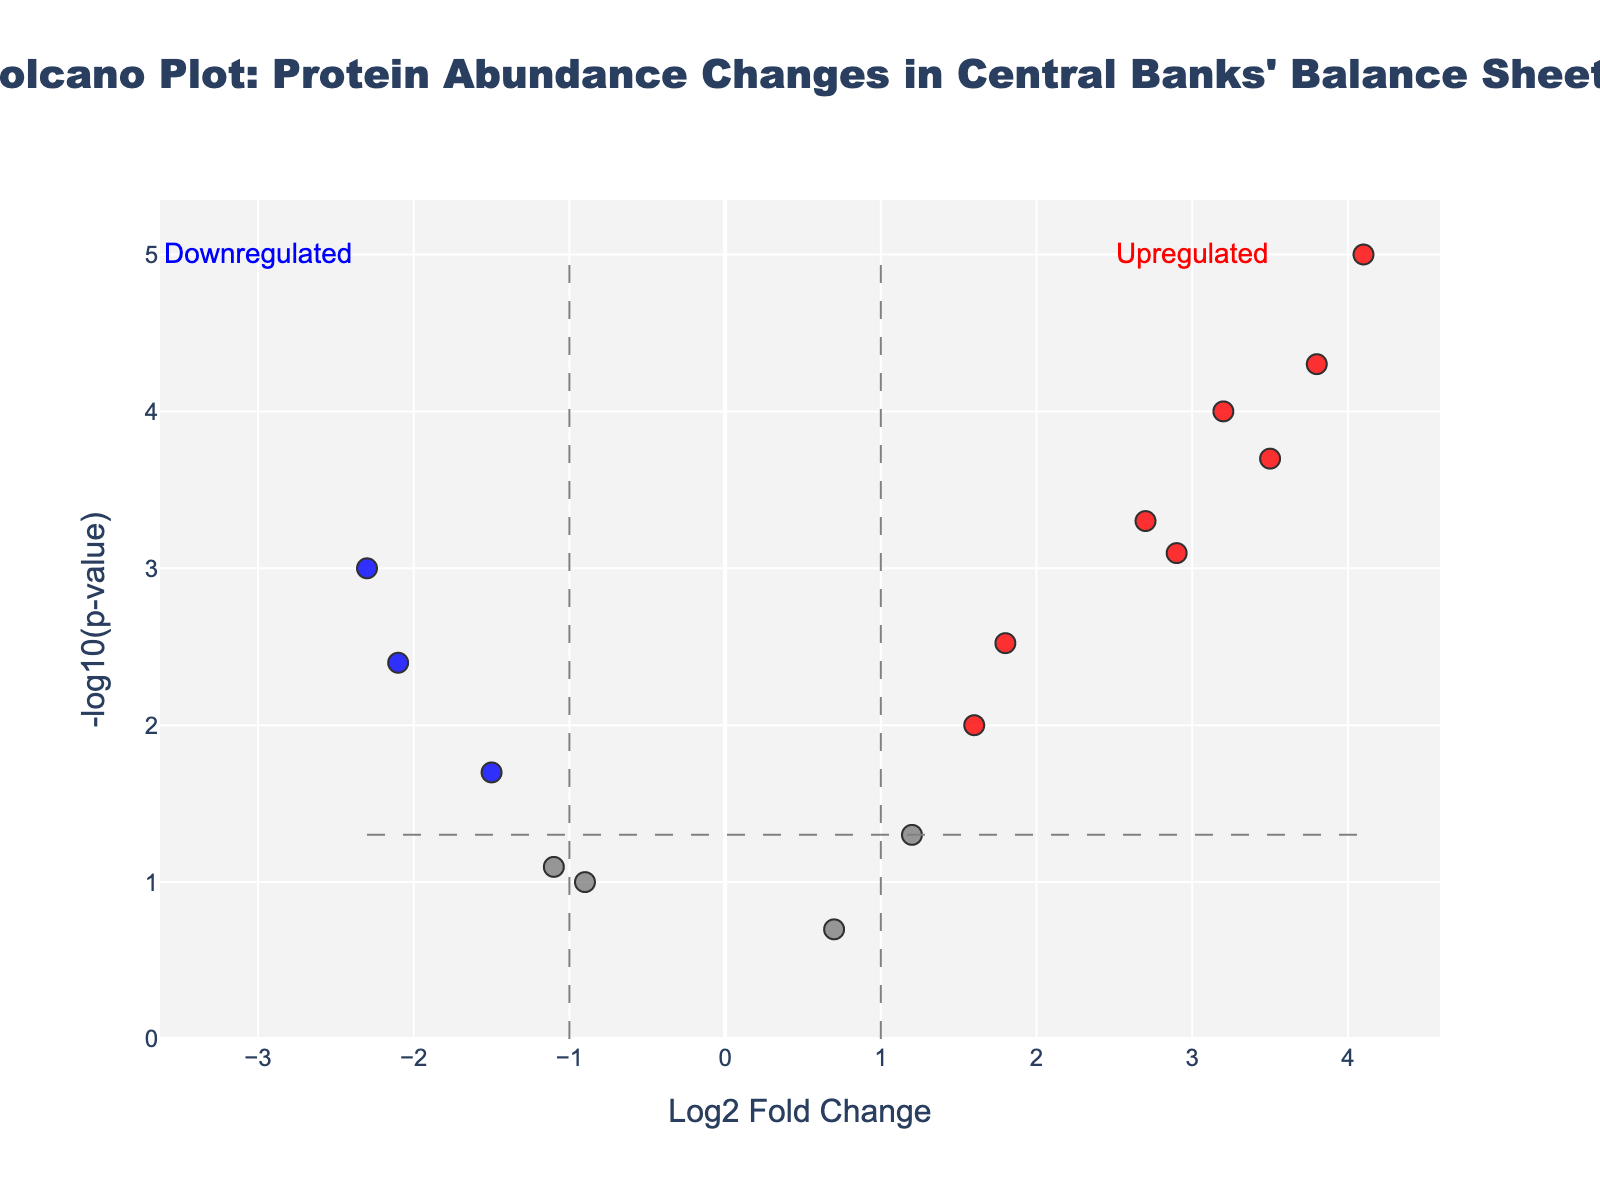What is the title of the volcano plot? The title is usually located at the top of the plot. It provides a general idea of the information being presented. In this figure, the title is "Volcano Plot: Protein Abundance Changes in Central Banks' Balance Sheets"
Answer: Volcano Plot: Protein Abundance Changes in Central Banks' Balance Sheets How many proteins have a Log2 Fold Change greater than 1 and a p-value less than 0.05? To answer this, count the proteins represented by red points (indicative of Log2 Fold Change > 1 and PValue < 0.05). These proteins are LIBOR2, REPOACT, TALF, TREASBOND, CPFF, PDCF, and ZIRP.
Answer: 7 Which protein exhibits the most significant decrease in abundance? The most significant decrease is indicated by a blue point with the lowest Log2 Fold Change. In this case, CBECE1 has the lowest Log2 Fold Change of -2.3.
Answer: CBECE1 How many data points fall into the "Upregulated" category? The "Upregulated" annotation refers to proteins with positive Log2 Fold Changes and significant p-values (red points). Referring to the red points on the right of the plot, there are 7 such points: LIBOR2, REPOACT, TALF, TREASBOND, CPFF, PDCF, and ZIRP.
Answer: 7 Which protein has the largest Log2 Fold Change? To find this, look for the point farthest to the right. TREASBOND has the highest Log2 Fold Change of 4.1.
Answer: TREASBOND How do the abundance changes of TAF and AMLF compare in terms of statistical significance? Compare the -log10(p-value) of TAF and AMLF. TAF has a -log10(p-value) of 2.39794 (p-value 0.004), while AMLF has a -log10(p-value) of 1.09691 (p-value 0.08). Thus, TAF shows a greater statistical significance.
Answer: TAF shows greater statistical significance Which proteins are neither significantly upregulated nor downregulated? These proteins are represented by grey points, indicating neither the Log2 Fold Change threshold nor the p-value threshold are met. By observing the grey points, FEDRES1, MMMF, AMLF, and TSLF fall into this category.
Answer: FEDRES1, MMMF, AMLF, TSLF What does the y-axis represent and how does it relate to p-values? The y-axis represents -log10(p-value). This transformation translates smaller p-values into larger values on the y-axis, emphasizing statistical significance. A low p-value results in a high -log10(p-value) value.
Answer: -log10(p-value); higher values indicate more significant changes Arrange the following proteins by their Log2 Fold Change: SWAPLINE, TAF, ABCP. By checking their Log2 Fold Change values: SWAPLINE (-1.5), TAF (-2.1), ABCP (1.6). Arrange these in increasing order.
Answer: TAF, SWAPLINE, ABCP 